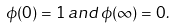<formula> <loc_0><loc_0><loc_500><loc_500>\phi ( 0 ) = 1 \, a n d \, \phi ( \infty ) = 0 .</formula> 